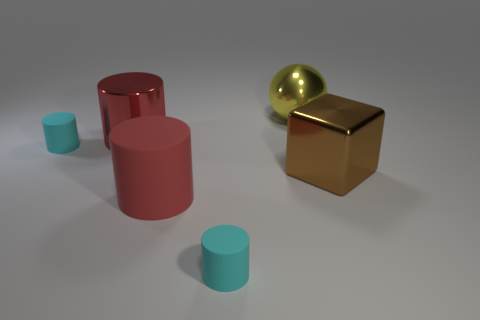Are there an equal number of tiny cylinders on the right side of the red metal object and big yellow things that are behind the big yellow shiny sphere?
Your answer should be very brief. No. There is a tiny cyan object in front of the block to the right of the big rubber thing; what is it made of?
Give a very brief answer. Rubber. What number of things are large cyan matte things or small cyan matte objects?
Your response must be concise. 2. What size is the metal cylinder that is the same color as the large rubber thing?
Provide a succinct answer. Large. Are there fewer cylinders than yellow metallic objects?
Your response must be concise. No. What is the size of the ball that is the same material as the big block?
Provide a short and direct response. Large. What size is the yellow metal thing?
Provide a short and direct response. Large. There is a yellow thing; what shape is it?
Ensure brevity in your answer.  Sphere. Is the color of the small rubber cylinder that is to the left of the large red rubber cylinder the same as the big metallic sphere?
Offer a very short reply. No. What size is the red shiny thing that is the same shape as the large matte thing?
Your answer should be compact. Large. 